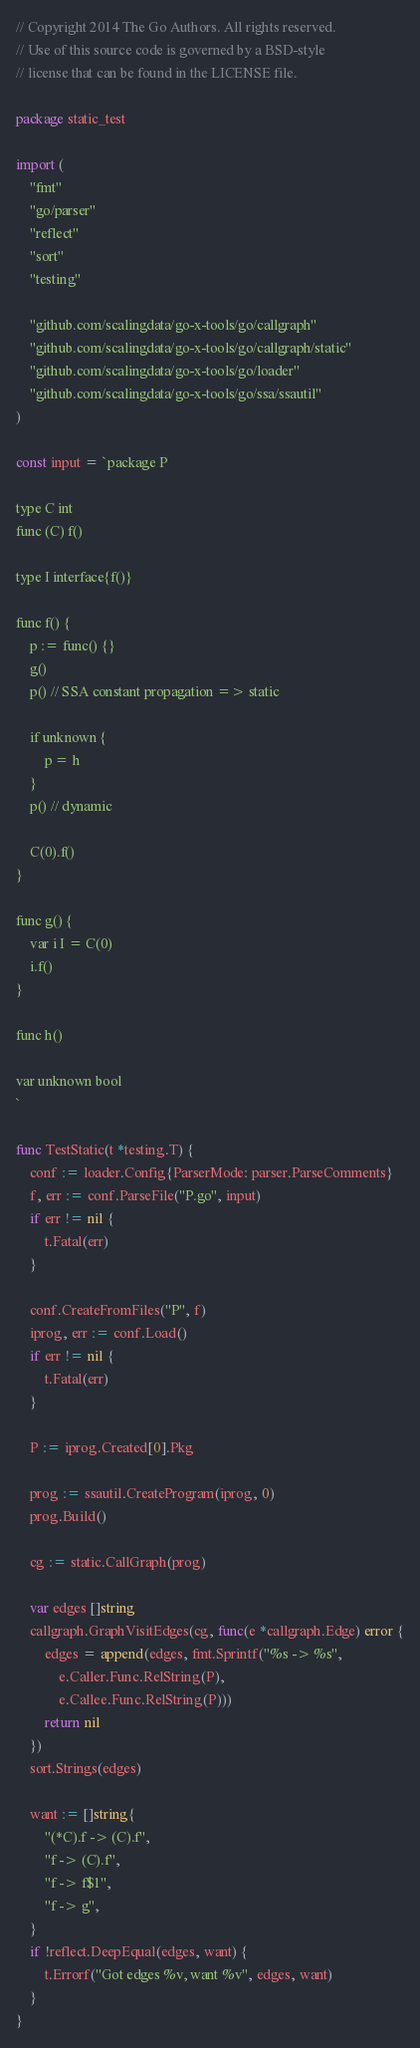<code> <loc_0><loc_0><loc_500><loc_500><_Go_>// Copyright 2014 The Go Authors. All rights reserved.
// Use of this source code is governed by a BSD-style
// license that can be found in the LICENSE file.

package static_test

import (
	"fmt"
	"go/parser"
	"reflect"
	"sort"
	"testing"

	"github.com/scalingdata/go-x-tools/go/callgraph"
	"github.com/scalingdata/go-x-tools/go/callgraph/static"
	"github.com/scalingdata/go-x-tools/go/loader"
	"github.com/scalingdata/go-x-tools/go/ssa/ssautil"
)

const input = `package P

type C int
func (C) f()

type I interface{f()}

func f() {
	p := func() {}
	g()
	p() // SSA constant propagation => static

	if unknown {
		p = h
	}
	p() // dynamic

	C(0).f()
}

func g() {
	var i I = C(0)
	i.f()
}

func h()

var unknown bool
`

func TestStatic(t *testing.T) {
	conf := loader.Config{ParserMode: parser.ParseComments}
	f, err := conf.ParseFile("P.go", input)
	if err != nil {
		t.Fatal(err)
	}

	conf.CreateFromFiles("P", f)
	iprog, err := conf.Load()
	if err != nil {
		t.Fatal(err)
	}

	P := iprog.Created[0].Pkg

	prog := ssautil.CreateProgram(iprog, 0)
	prog.Build()

	cg := static.CallGraph(prog)

	var edges []string
	callgraph.GraphVisitEdges(cg, func(e *callgraph.Edge) error {
		edges = append(edges, fmt.Sprintf("%s -> %s",
			e.Caller.Func.RelString(P),
			e.Callee.Func.RelString(P)))
		return nil
	})
	sort.Strings(edges)

	want := []string{
		"(*C).f -> (C).f",
		"f -> (C).f",
		"f -> f$1",
		"f -> g",
	}
	if !reflect.DeepEqual(edges, want) {
		t.Errorf("Got edges %v, want %v", edges, want)
	}
}
</code> 